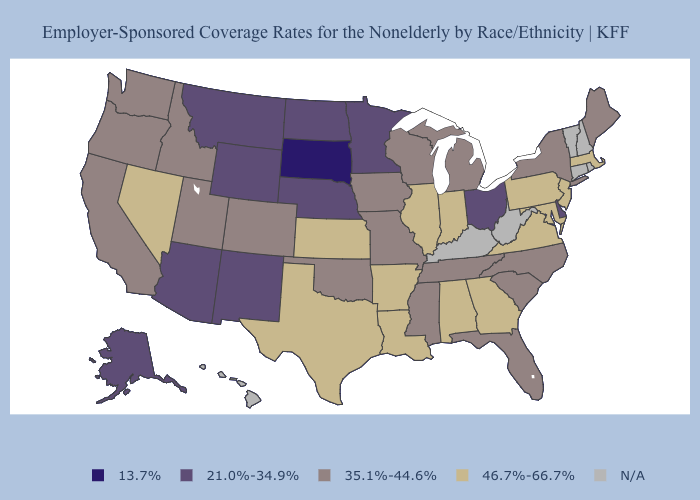Name the states that have a value in the range N/A?
Keep it brief. Connecticut, Hawaii, Kentucky, New Hampshire, Rhode Island, Vermont, West Virginia. What is the lowest value in states that border Nevada?
Quick response, please. 21.0%-34.9%. Does Michigan have the lowest value in the MidWest?
Short answer required. No. Name the states that have a value in the range 35.1%-44.6%?
Answer briefly. California, Colorado, Florida, Idaho, Iowa, Maine, Michigan, Mississippi, Missouri, New York, North Carolina, Oklahoma, Oregon, South Carolina, Tennessee, Utah, Washington, Wisconsin. Is the legend a continuous bar?
Give a very brief answer. No. What is the value of West Virginia?
Concise answer only. N/A. What is the lowest value in states that border New Jersey?
Answer briefly. 21.0%-34.9%. What is the value of Florida?
Write a very short answer. 35.1%-44.6%. Does New Mexico have the highest value in the USA?
Be succinct. No. Which states have the highest value in the USA?
Write a very short answer. Alabama, Arkansas, Georgia, Illinois, Indiana, Kansas, Louisiana, Maryland, Massachusetts, Nevada, New Jersey, Pennsylvania, Texas, Virginia. Name the states that have a value in the range N/A?
Be succinct. Connecticut, Hawaii, Kentucky, New Hampshire, Rhode Island, Vermont, West Virginia. Does Arkansas have the highest value in the South?
Write a very short answer. Yes. Does Mississippi have the lowest value in the USA?
Write a very short answer. No. Does New Mexico have the lowest value in the West?
Quick response, please. Yes. Does Virginia have the highest value in the South?
Answer briefly. Yes. 